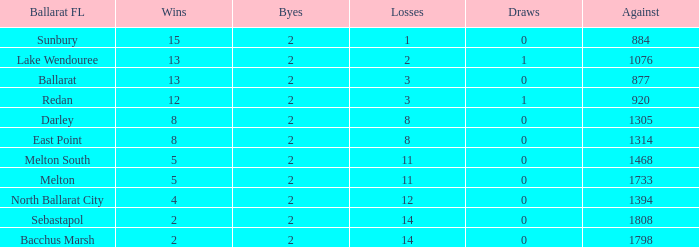How many Byes have Against of 1076 and Wins smaller than 13? None. 